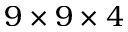Convert formula to latex. <formula><loc_0><loc_0><loc_500><loc_500>9 \times 9 \times 4</formula> 